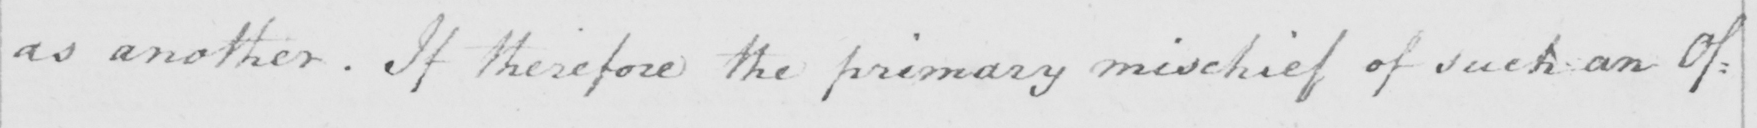What is written in this line of handwriting? as another . If therefore the primary mischief of such an Of: 